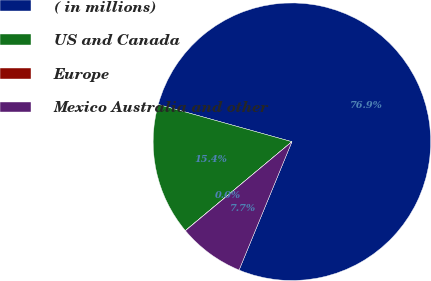Convert chart. <chart><loc_0><loc_0><loc_500><loc_500><pie_chart><fcel>( in millions)<fcel>US and Canada<fcel>Europe<fcel>Mexico Australia and other<nl><fcel>76.89%<fcel>15.39%<fcel>0.02%<fcel>7.7%<nl></chart> 